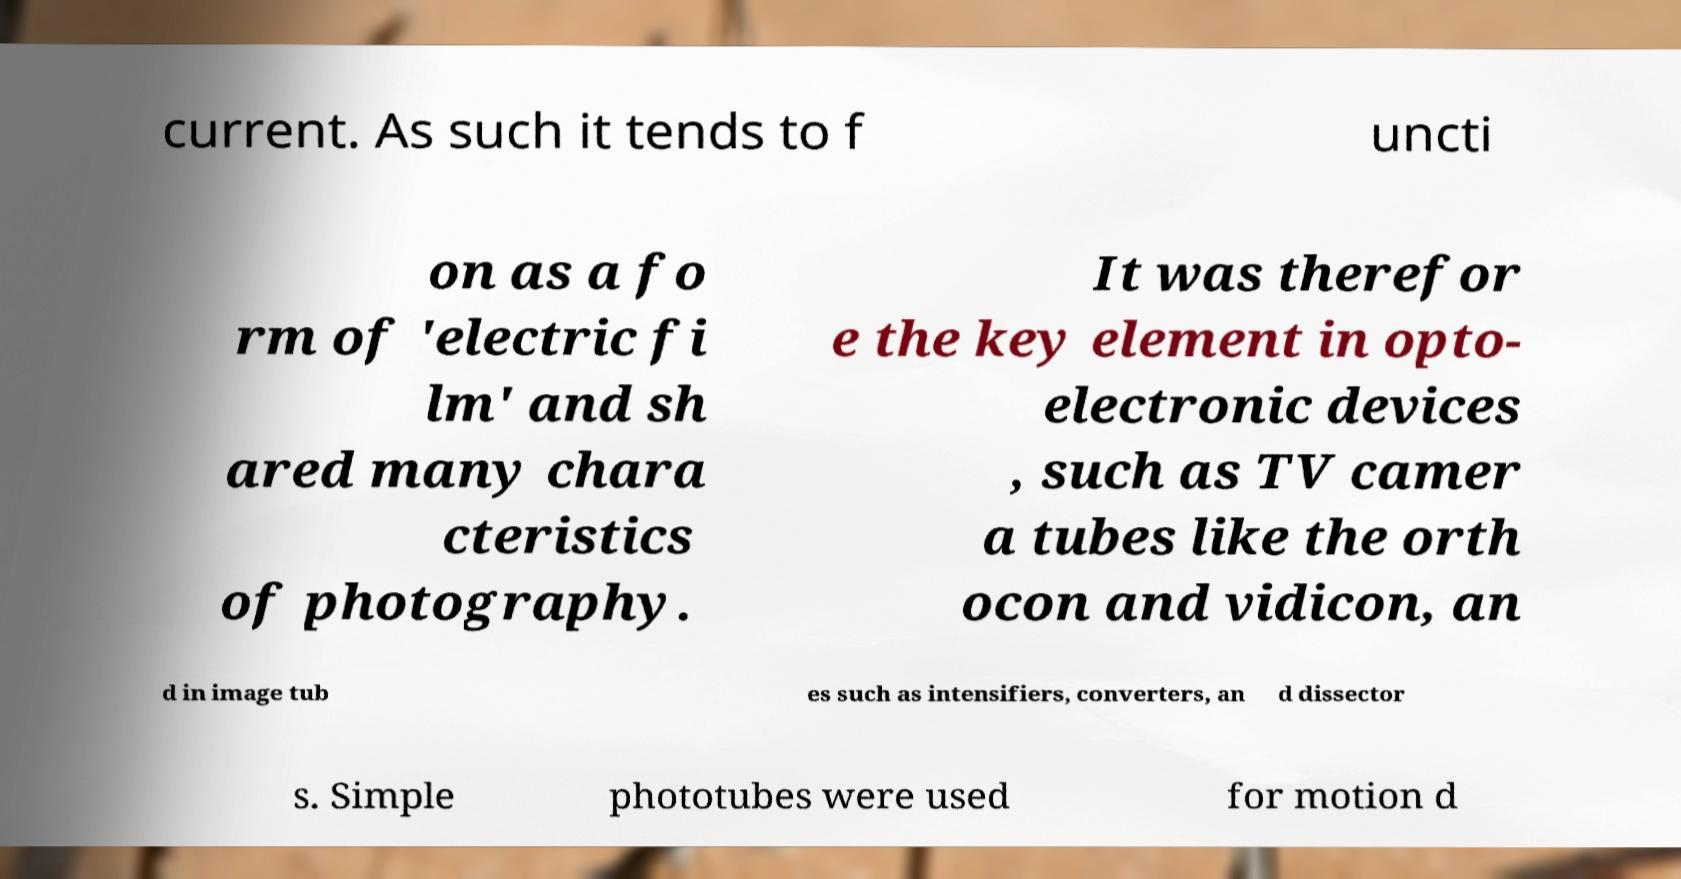Can you read and provide the text displayed in the image?This photo seems to have some interesting text. Can you extract and type it out for me? current. As such it tends to f uncti on as a fo rm of 'electric fi lm' and sh ared many chara cteristics of photography. It was therefor e the key element in opto- electronic devices , such as TV camer a tubes like the orth ocon and vidicon, an d in image tub es such as intensifiers, converters, an d dissector s. Simple phototubes were used for motion d 